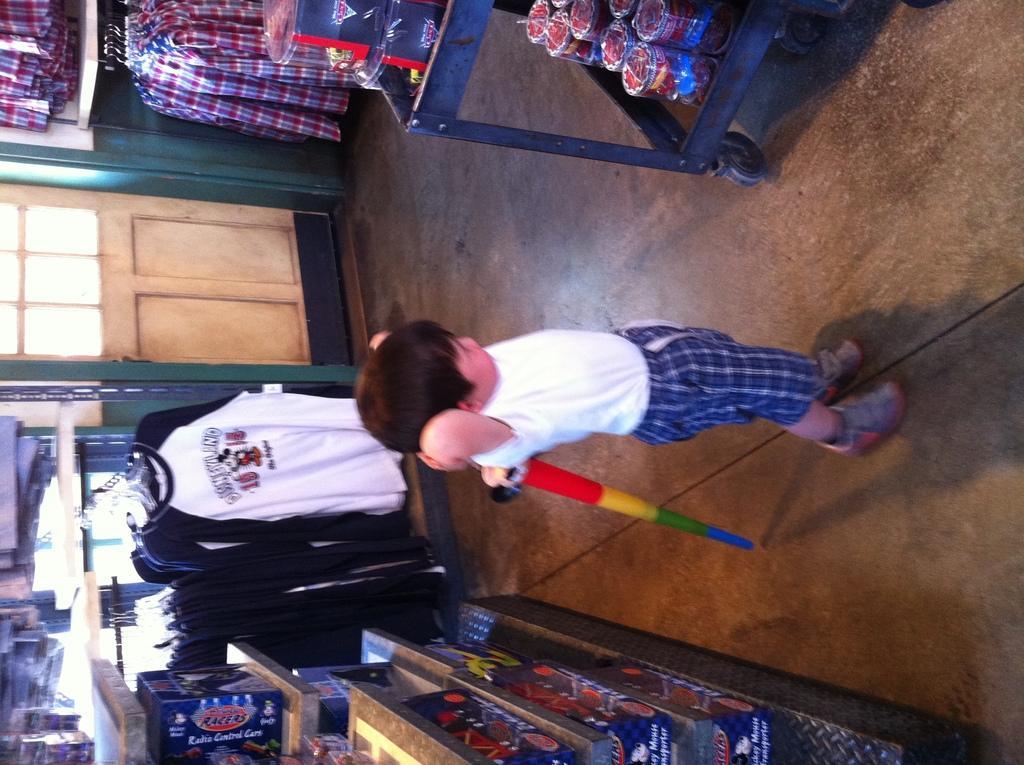How would you summarize this image in a sentence or two? In this image there is a kid standing on the floor. He is holding an object. Top of the image there is a trolley having few objects. Left top few clothes are hanging. Bottom of the image there is a rack having few objects. Behind few clothes are hanging from a metal rod. Left side there is a wall having a door. 